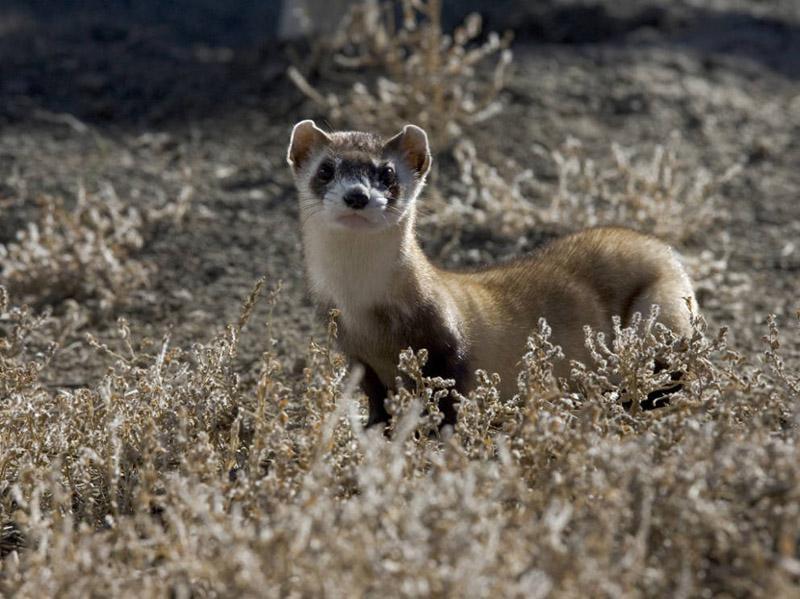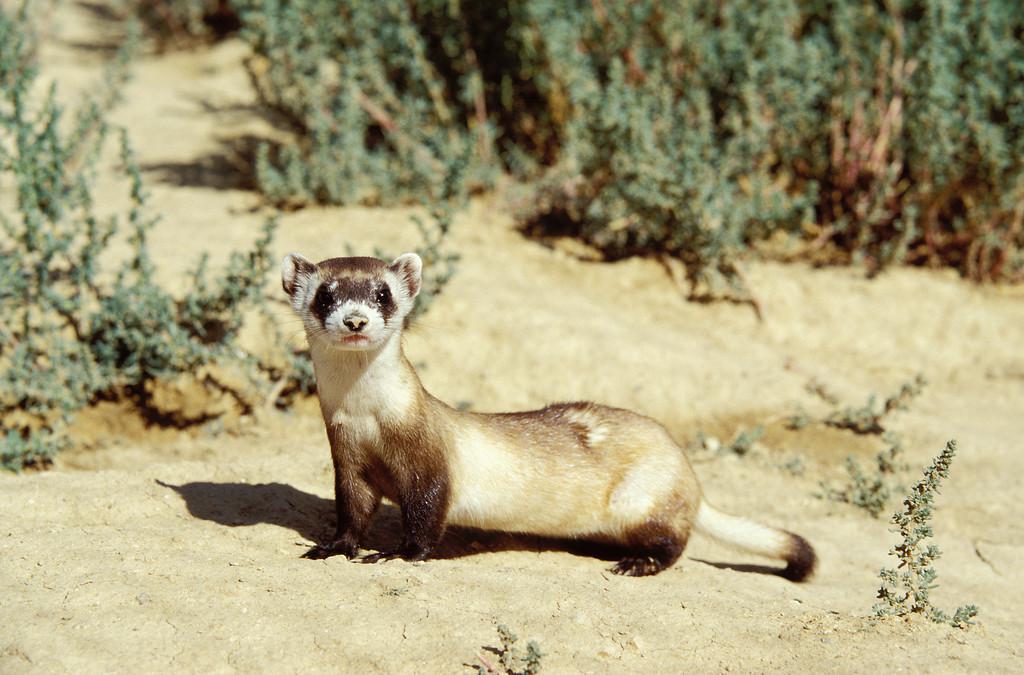The first image is the image on the left, the second image is the image on the right. Analyze the images presented: Is the assertion "A ferret is partially inside of a hole." valid? Answer yes or no. No. The first image is the image on the left, the second image is the image on the right. For the images displayed, is the sentence "In at least one image a Mustelid can be seen sticking its head out of a visible dirt hole." factually correct? Answer yes or no. No. 